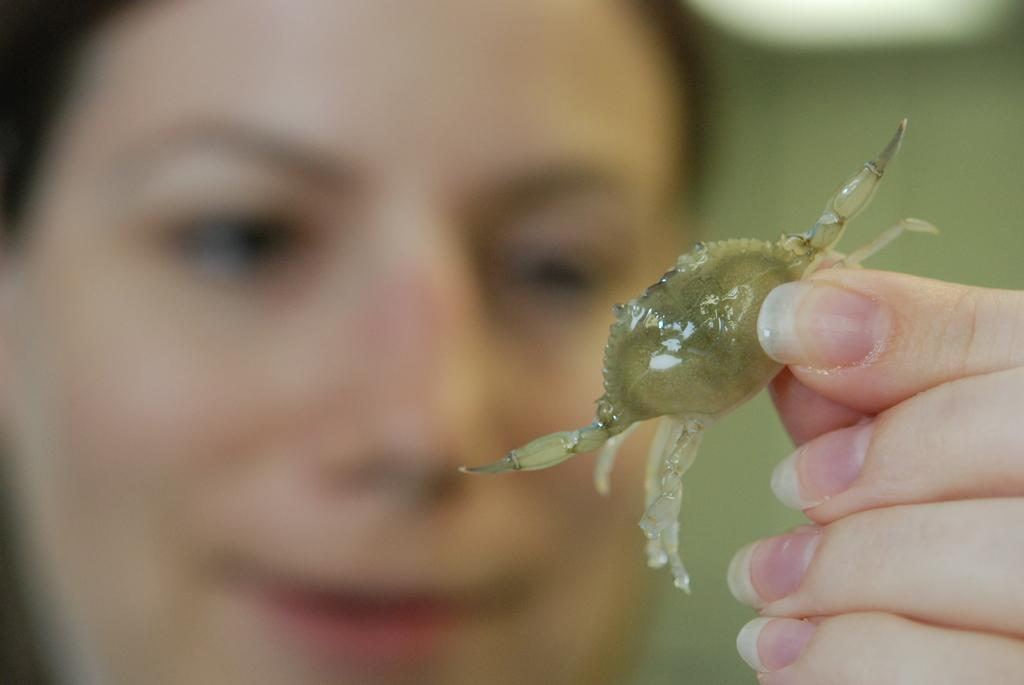Who or what is the main subject in the image? There is a person in the image. What is the person holding in the image? The person is holding a crab. What type of appliance can be seen in the image? There is no appliance present in the image. Can you provide an example of a decision made by the person in the image? There is not enough information in the image to determine any decisions made by the person. 